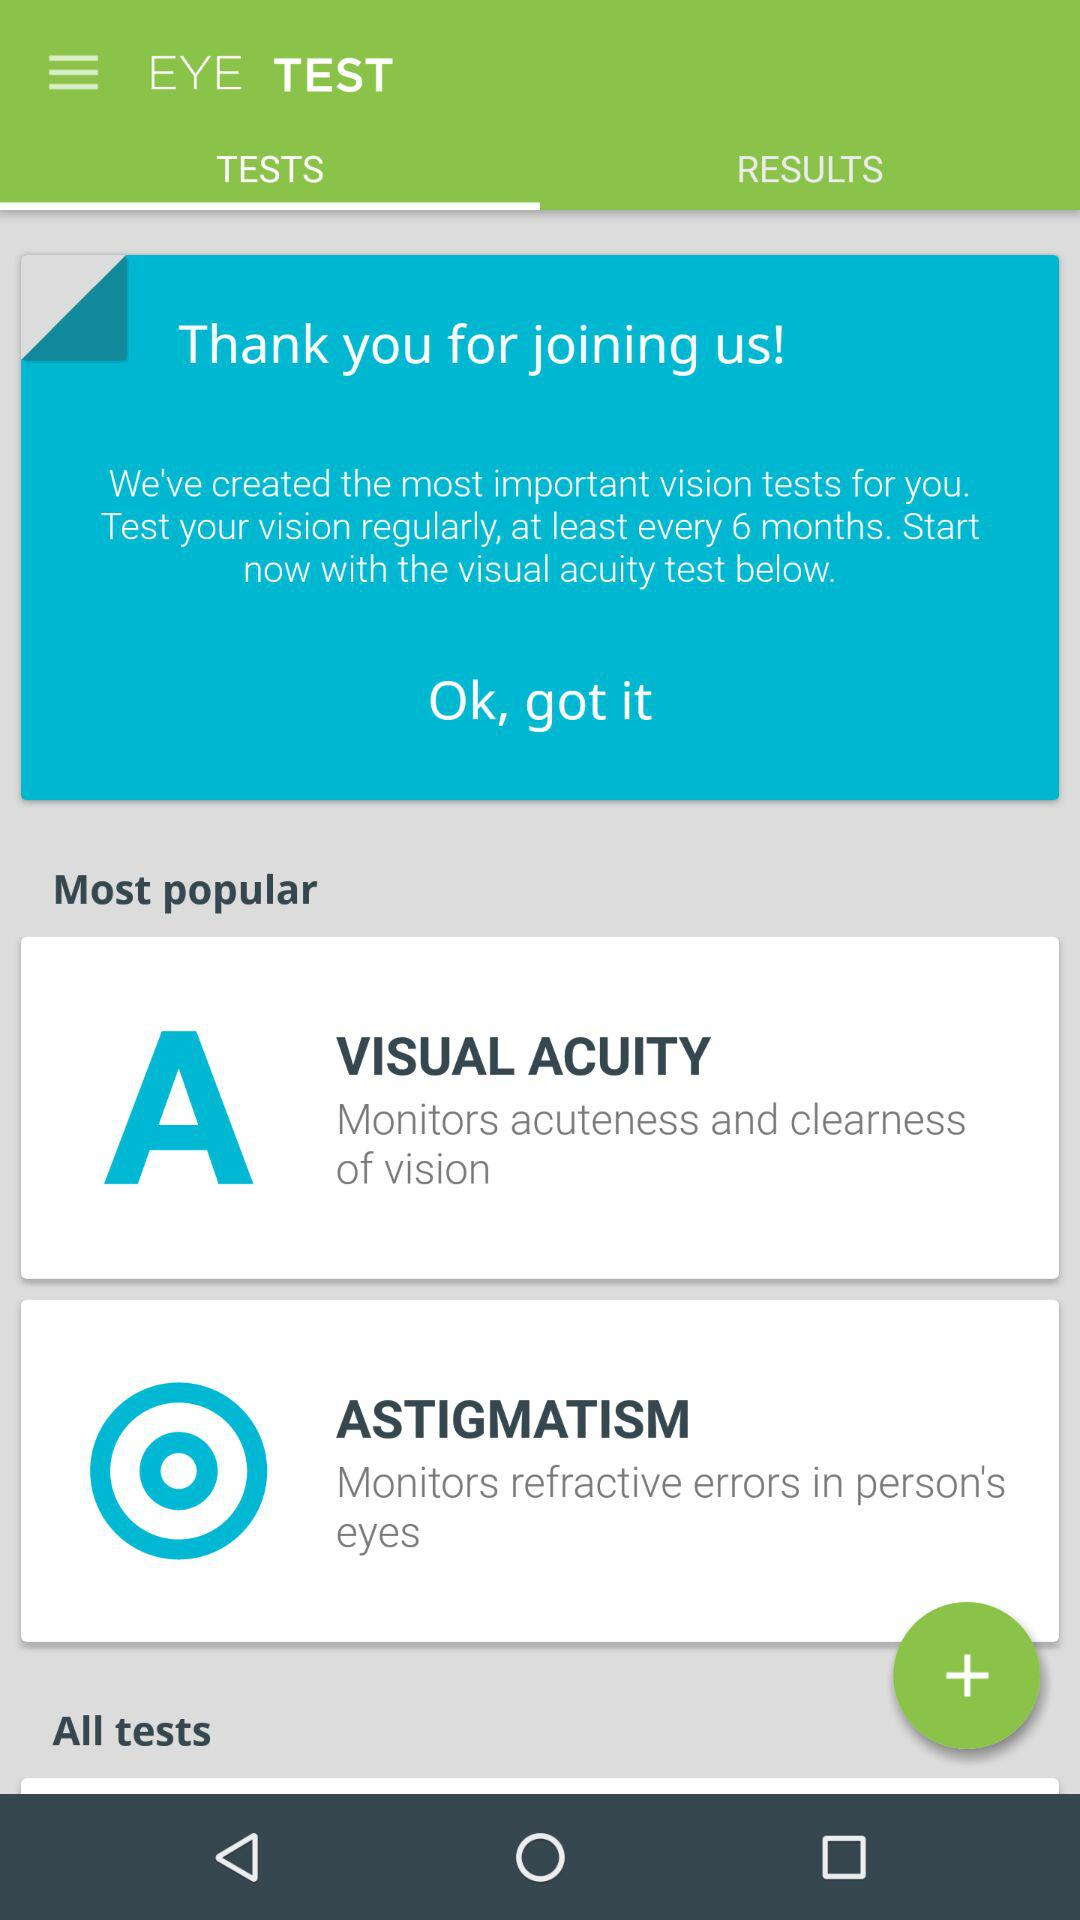How many tests are in the 'Most popular' section?
Answer the question using a single word or phrase. 2 